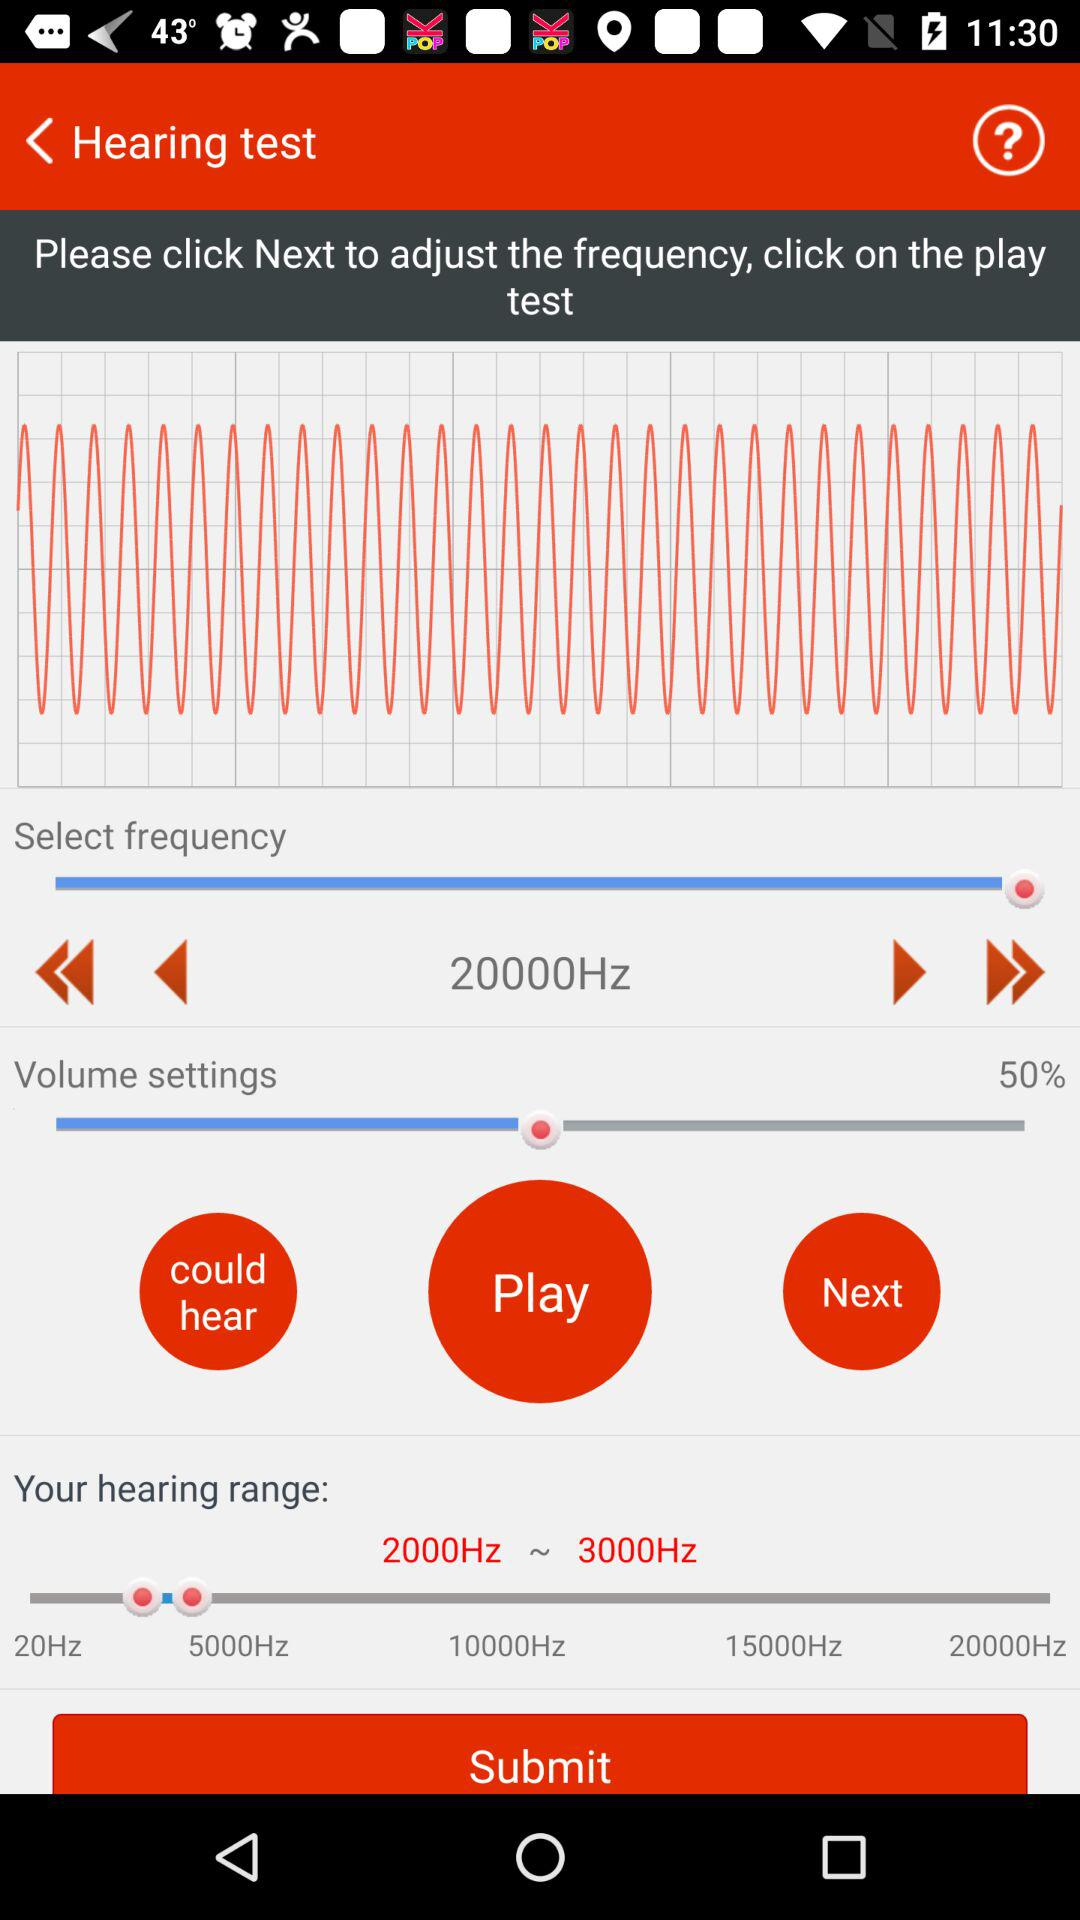What is the hearing range? The hearing range is from 2000Hz to 3000Hz. 